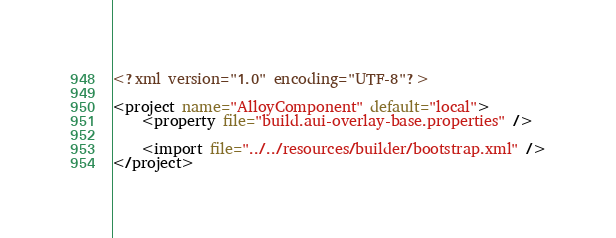<code> <loc_0><loc_0><loc_500><loc_500><_XML_><?xml version="1.0" encoding="UTF-8"?>

<project name="AlloyComponent" default="local">
	<property file="build.aui-overlay-base.properties" />

	<import file="../../resources/builder/bootstrap.xml" />
</project></code> 